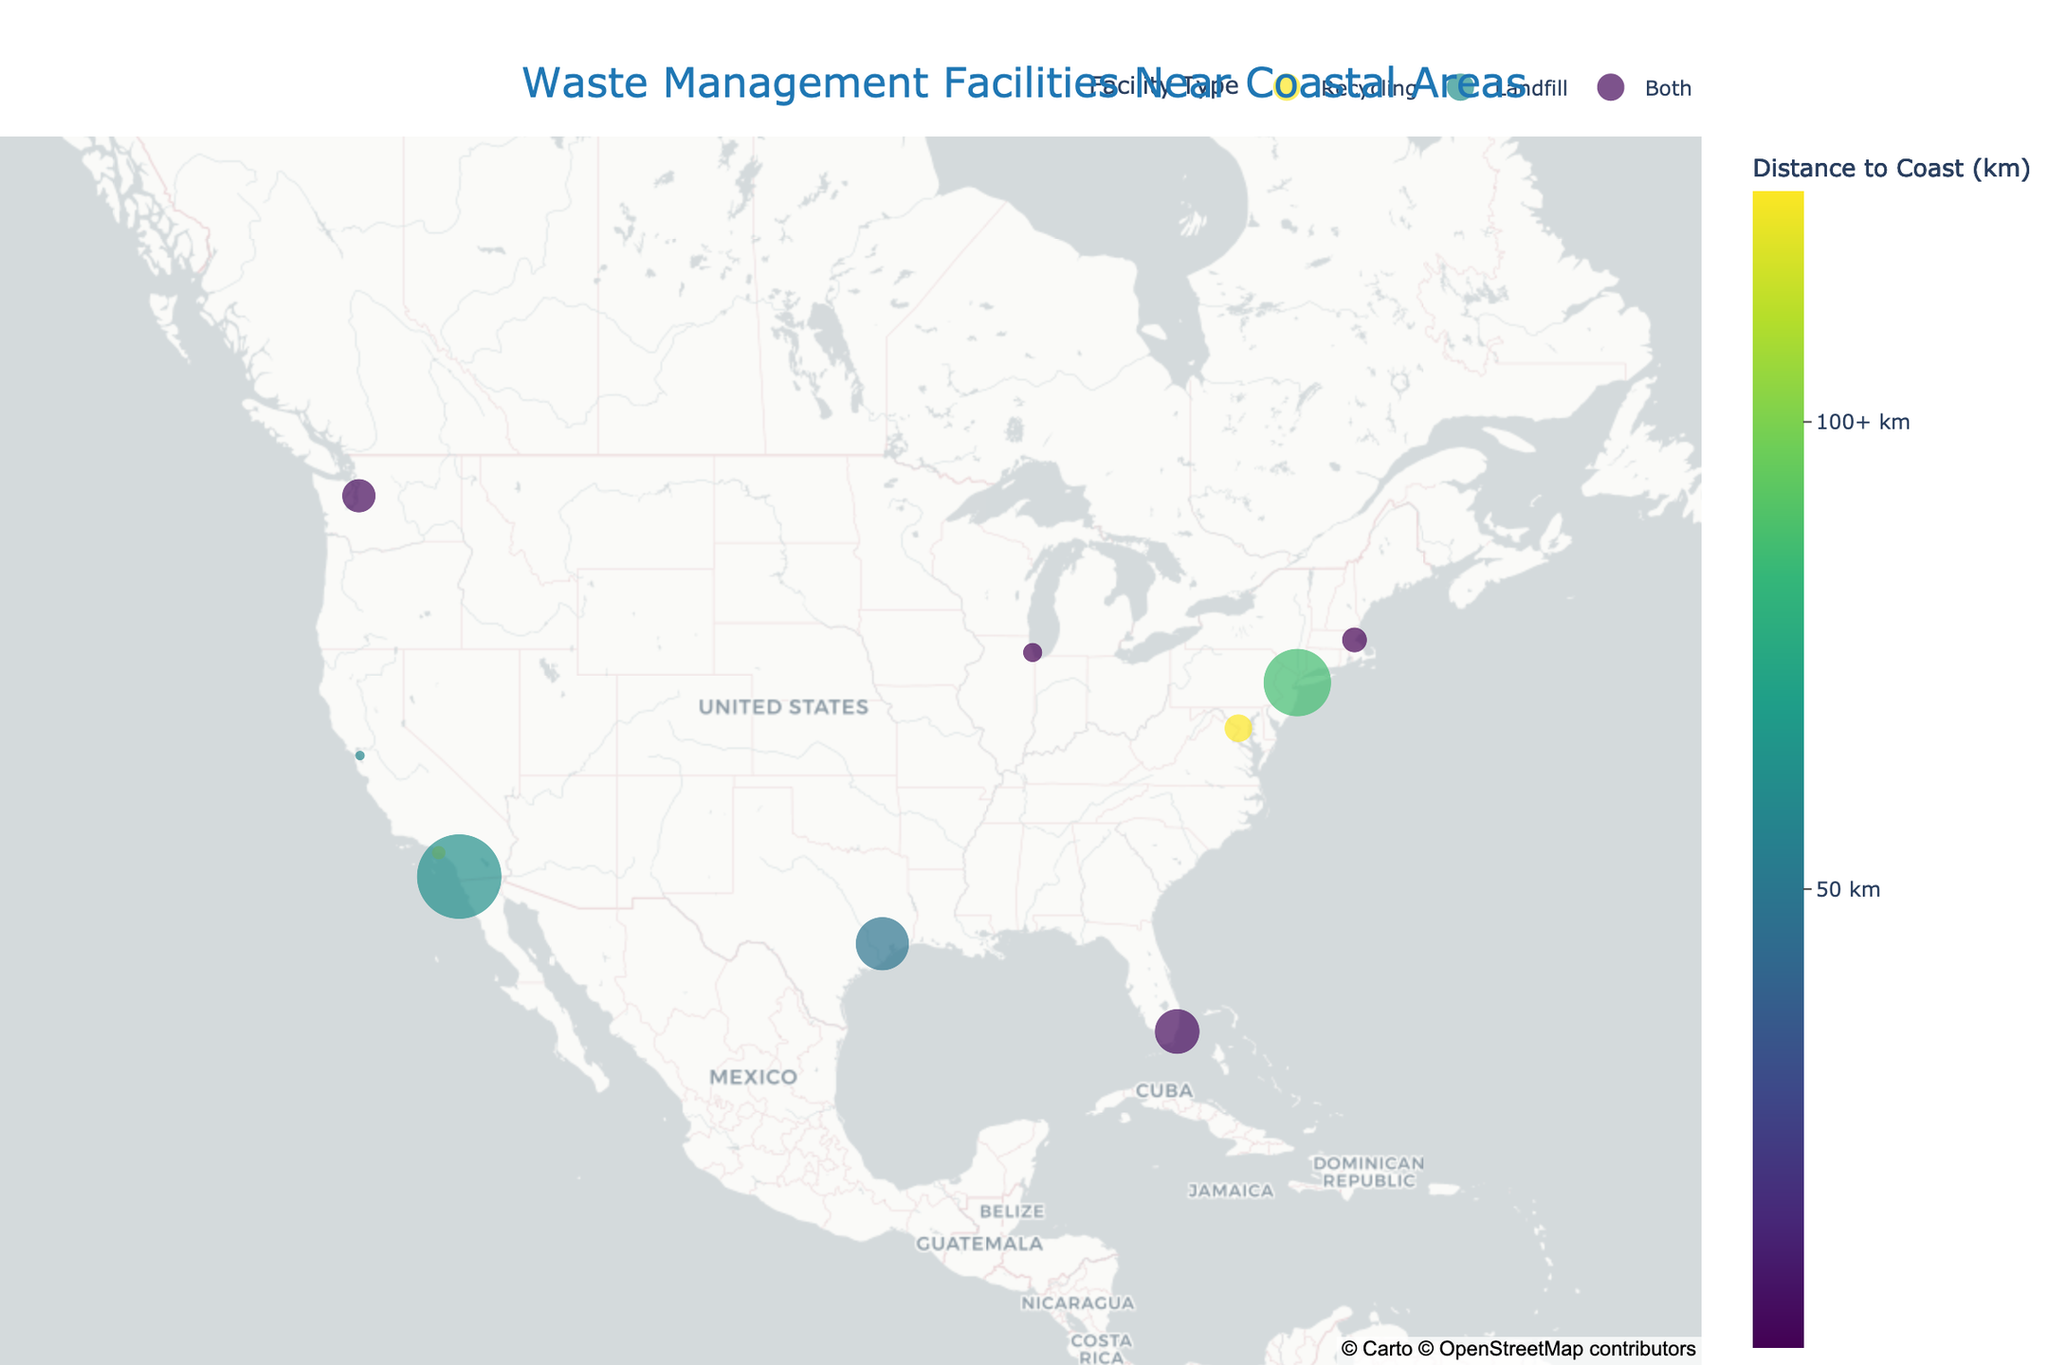What is the title of the figure? The title of the figure is usually displayed prominently at the top. In this case, it reads "Waste Management Facilities Near Coastal Areas".
Answer: Waste Management Facilities Near Coastal Areas How many recycling centers are near coastal areas? By observing the legend, the recycling centers are denoted as "Recycling". Counting the markers with this legend, you find there are five recycling centers.
Answer: 5 Which facility is closest to the coast, and what is its distance? By examining the distance to coast color scale and the position of markers, "Boston Zero Waste Facility" has the shortest distance, indicated as approximately 0.9 km on hover information.
Answer: Boston Zero Waste Facility, 0.9 km Which facility has the largest capacity, and what is it? Looking at the marker sizes, the largest one corresponds to "San Diego Waste Management Facility". On hover, it shows a capacity of 1500 tons/day.
Answer: San Diego Waste Management Facility, 1500 tons/day What is the combined capacity of the two facilities that are more than 100 km from the coast? Identifying the markers with a distance greater than 100 km from the color scale, "DC Fort Totten Transfer Station" is the only one with a capacity of 500 tons/day.
Answer: 500 tons/day What is the average distance to the coast for facilities marked as "Both"? Identify the distances for Seattle (3.7 km), Miami-Dade (4.2 km), Boston (0.9 km), Houston (48.3 km), and DC (124.7 km). Add these and divide by 5. Calculation steps: (3.7 + 4.2 + 0.9 + 48.3 + 124.7) / 5 = 181.8 / 5 = 36.36 km
Answer: 36.36 km Which city has two types of facility functions and is closest to the coast, and how far is it? Determine which cities have both functions and check their distances: Seattle, Miami-Dade, Boston, Houston, and DC. "Boston Zero Waste Facility" is closest at 0.9 km.
Answer: Boston, 0.9 km Are there more facilities within 10 km or beyond 10 km from the coast? Count the number of facilities within 10 km by observing the color scale: Long Beach, Oakland, Seattle, Miami-Dade, Chicago, Boston, NYC (totals 7). The remaining facilities (San Diego, Houston, DC) are beyond 10 km (totals 3).
Answer: More within 10 km Which facility type has the highest average capacity, and what is it? Calculate average capacities for each type. Recycling: (250 + 180 + 350 + 1200) / 4 = 495 tons/day. Landfill: 1500 / 1 = 1500 tons/day. Both: (600 + 800 + 450 + 950 + 500) / 5 = 660 tons/day. Landfill has the highest average capacity.
Answer: Landfill, 1500 tons/day 